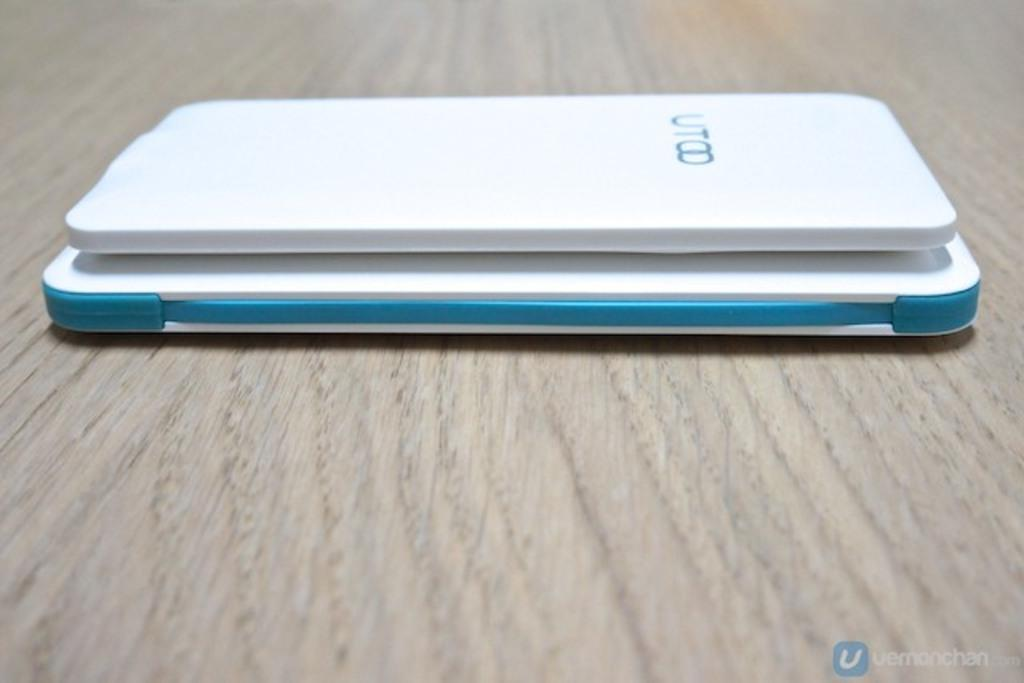What objects in the image are electronic gadgets? There are two electronic gadgets in the image. What can be said about the color of the electronic gadgets? The electronic gadgets are white in color. How many cherries are on the white electronic gadgets in the image? There are no cherries present in the image, as it only features two white electronic gadgets. What type of offer is being made by the sheep in the image? There are no sheep present in the image, so no offer can be made by them. 